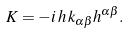Convert formula to latex. <formula><loc_0><loc_0><loc_500><loc_500>K = - i \, h \, k _ { \alpha \beta } h ^ { \alpha \beta } .</formula> 